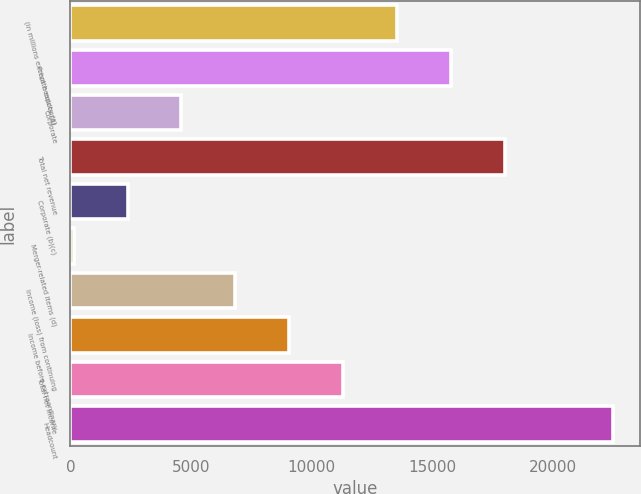<chart> <loc_0><loc_0><loc_500><loc_500><bar_chart><fcel>(in millions except headcount)<fcel>Private equity (a)<fcel>Corporate<fcel>Total net revenue<fcel>Corporate (b)(c)<fcel>Merger-related items (d)<fcel>Income (loss) from continuing<fcel>Income before extraordinary<fcel>Total net income<fcel>Headcount<nl><fcel>13559.2<fcel>15797.4<fcel>4606.4<fcel>18035.6<fcel>2368.2<fcel>130<fcel>6844.6<fcel>9082.8<fcel>11321<fcel>22512<nl></chart> 